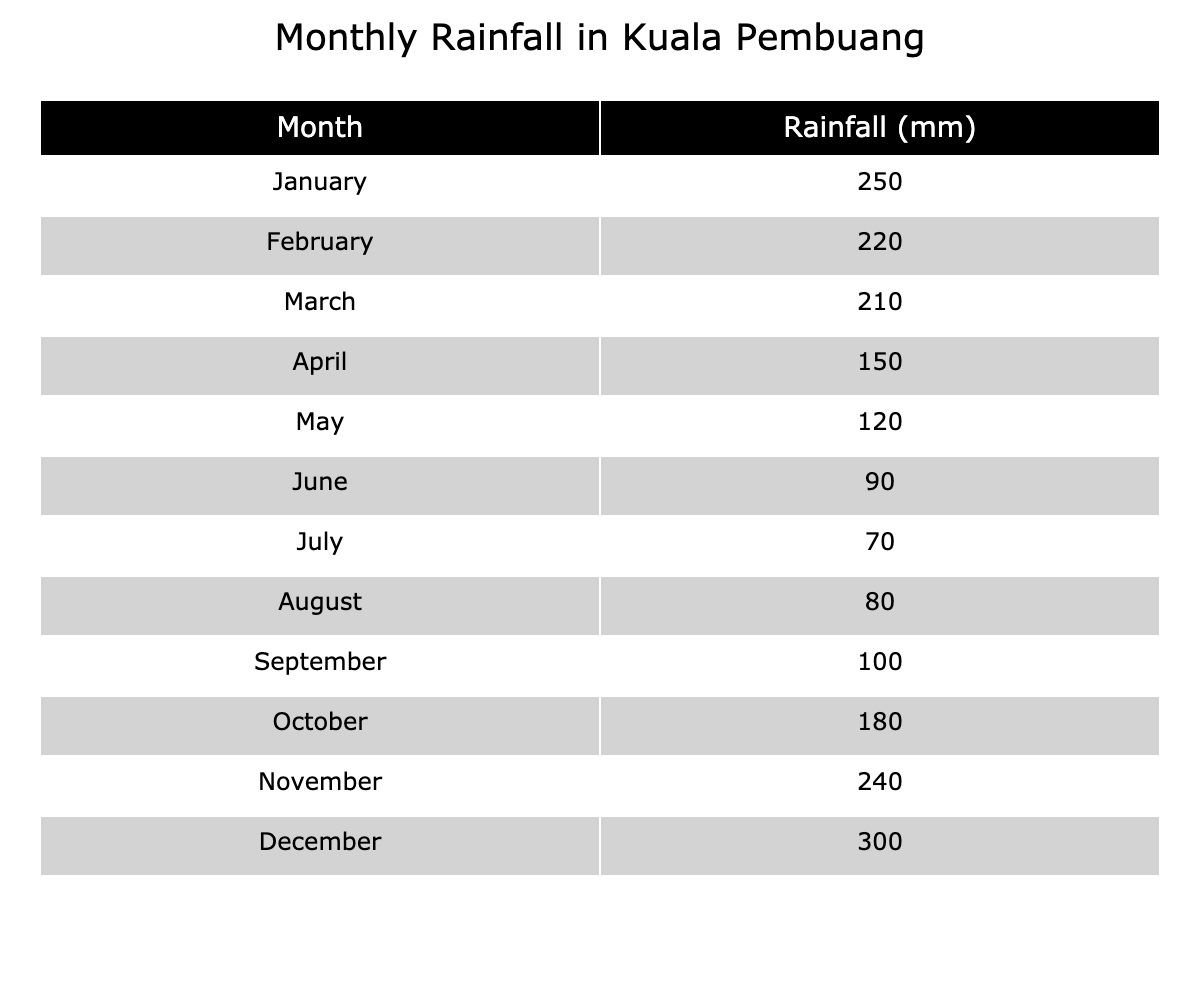What was the total amount of rainfall in Kuala Pembuang from January to December? To find the total rainfall for the year, we add together the monthly rainfall amounts: 250 + 220 + 210 + 150 + 120 + 90 + 70 + 80 + 100 + 180 + 240 + 300 = 1,800 mm.
Answer: 1,800 mm Which month had the highest rainfall? Comparing the monthly rainfall values, December has the highest value at 300 mm.
Answer: December What is the average monthly rainfall for the year? The total rainfall for the year is 1,800 mm, and there are 12 months. To find the average, we divide the total by the number of months: 1,800 / 12 = 150 mm.
Answer: 150 mm Did the rainfall increase or decrease from May to August? The rainfall in May is 120 mm and in August is 80 mm. Since 80 mm is less than 120 mm, the rainfall decreased from May to August.
Answer: Decreased Which month saw more rainfall, November or March? The rainfall in November is 240 mm, while in March it is 210 mm. Comparing these amounts, November had more rainfall than March.
Answer: November What is the difference in rainfall between the wettest month and the driest month? The wettest month is December with 300 mm, and the driest month is July with 70 mm. The difference is calculated as 300 - 70 = 230 mm.
Answer: 230 mm Are there any months with rainfall below 100 mm? The months with rainfall below 100 mm are June (90 mm) and July (70 mm). Therefore, it is true that there are months with rainfall below 100 mm.
Answer: Yes If we consider June and July, what is the total rainfall during these two months? June has 90 mm and July has 70 mm. Adding these values together: 90 + 70 = 160 mm.
Answer: 160 mm In how many months did Kuala Pembuang receive more than 200 mm of rainfall? The months with more than 200 mm of rainfall are January (250 mm), November (240 mm), and December (300 mm). This totals to 3 months.
Answer: 3 months What was the change in rainfall from April to October? April received 150 mm and October received 180 mm. To find the change, we subtract April's rainfall from October's: 180 - 150 = 30 mm. Thus, there was an increase of 30 mm.
Answer: Increased by 30 mm 